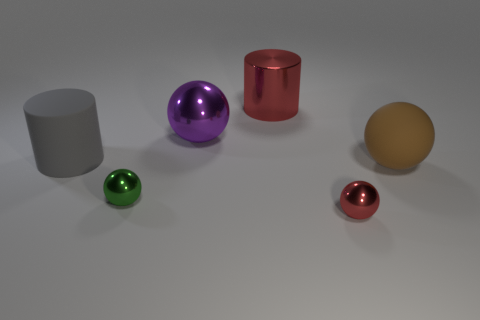How many brown rubber blocks are the same size as the gray rubber cylinder?
Offer a terse response. 0. What is the shape of the red metal object that is in front of the large rubber thing to the left of the big brown rubber object?
Keep it short and to the point. Sphere. Is the number of large purple metal things less than the number of tiny cyan metallic things?
Offer a terse response. No. What is the color of the thing in front of the green object?
Offer a very short reply. Red. There is a big object that is both left of the large red shiny object and on the right side of the green thing; what is it made of?
Offer a terse response. Metal. The small red thing that is made of the same material as the purple thing is what shape?
Keep it short and to the point. Sphere. How many big purple things are right of the red thing that is behind the red sphere?
Make the answer very short. 0. How many small objects are both left of the tiny red object and in front of the small green shiny ball?
Make the answer very short. 0. How many other objects are there of the same material as the red cylinder?
Provide a succinct answer. 3. There is a tiny metallic object on the left side of the red shiny object in front of the gray matte cylinder; what color is it?
Your response must be concise. Green. 